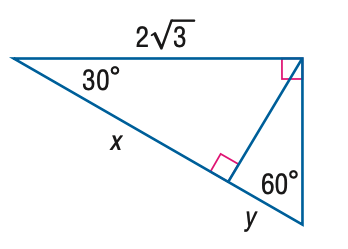Answer the mathemtical geometry problem and directly provide the correct option letter.
Question: Find y.
Choices: A: \frac { \sqrt { 3 } } { 3 } B: 1 C: \sqrt { 3 } D: 3 B 